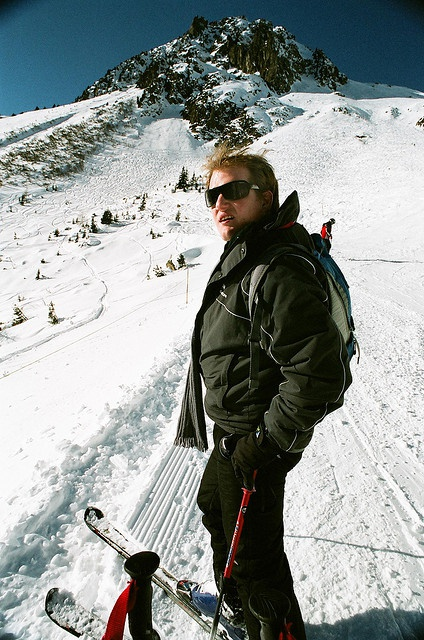Describe the objects in this image and their specific colors. I can see people in black, gray, darkgreen, and lightgray tones, backpack in black, lightgray, gray, and darkgray tones, skis in black, lightgray, darkgray, and gray tones, and people in black, red, brown, and gray tones in this image. 